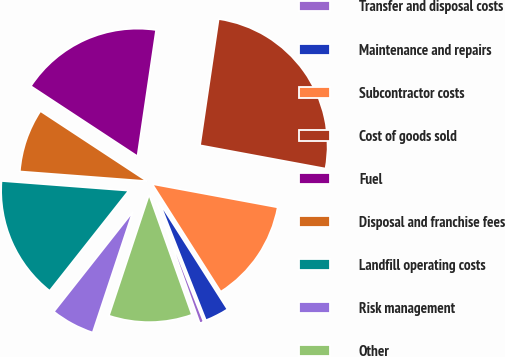Convert chart. <chart><loc_0><loc_0><loc_500><loc_500><pie_chart><fcel>Transfer and disposal costs<fcel>Maintenance and repairs<fcel>Subcontractor costs<fcel>Cost of goods sold<fcel>Fuel<fcel>Disposal and franchise fees<fcel>Landfill operating costs<fcel>Risk management<fcel>Other<nl><fcel>0.53%<fcel>3.04%<fcel>13.06%<fcel>25.59%<fcel>18.07%<fcel>8.05%<fcel>15.57%<fcel>5.54%<fcel>10.55%<nl></chart> 